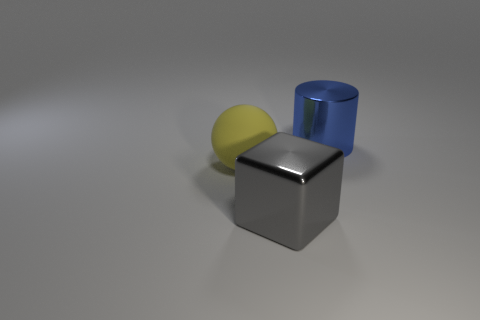What time of day does the lighting in this picture suggest? The lighting in the picture does not strongly suggest any particular time of day since the image appears to be taken in a controlled indoor setting with artificial lighting. The shadows are soft and diffused, which could indicate an overhead light source typical for indoor photography. 